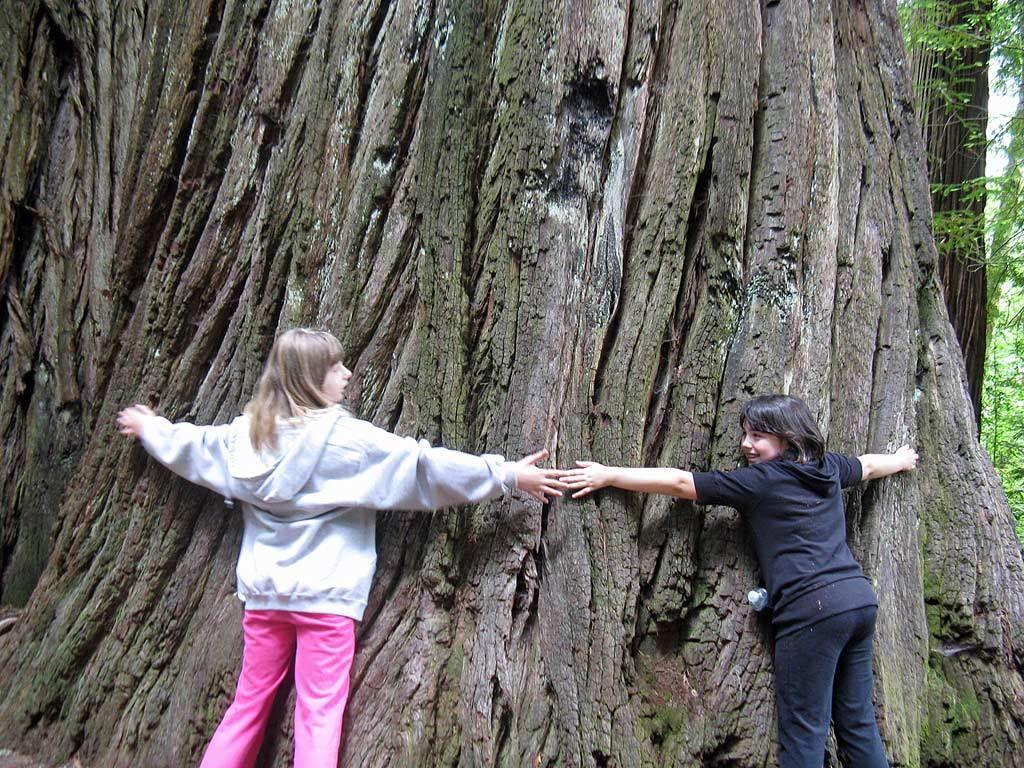How would you summarize this image in a sentence or two? In this image, there are a few people. We can see the trunks of the trees. We can also see some trees on the right. 